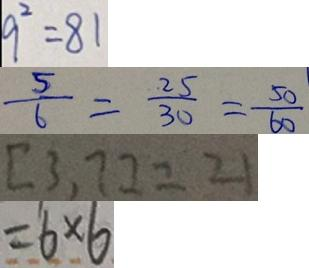<formula> <loc_0><loc_0><loc_500><loc_500>9 ^ { 2 } = 8 1 
 \frac { 5 } { 6 } = \frac { 2 5 } { 3 0 } = \frac { 5 0 } { 6 0 } 
 [ 3 , 7 ] = 2 1 
 = 6 \times 6</formula> 